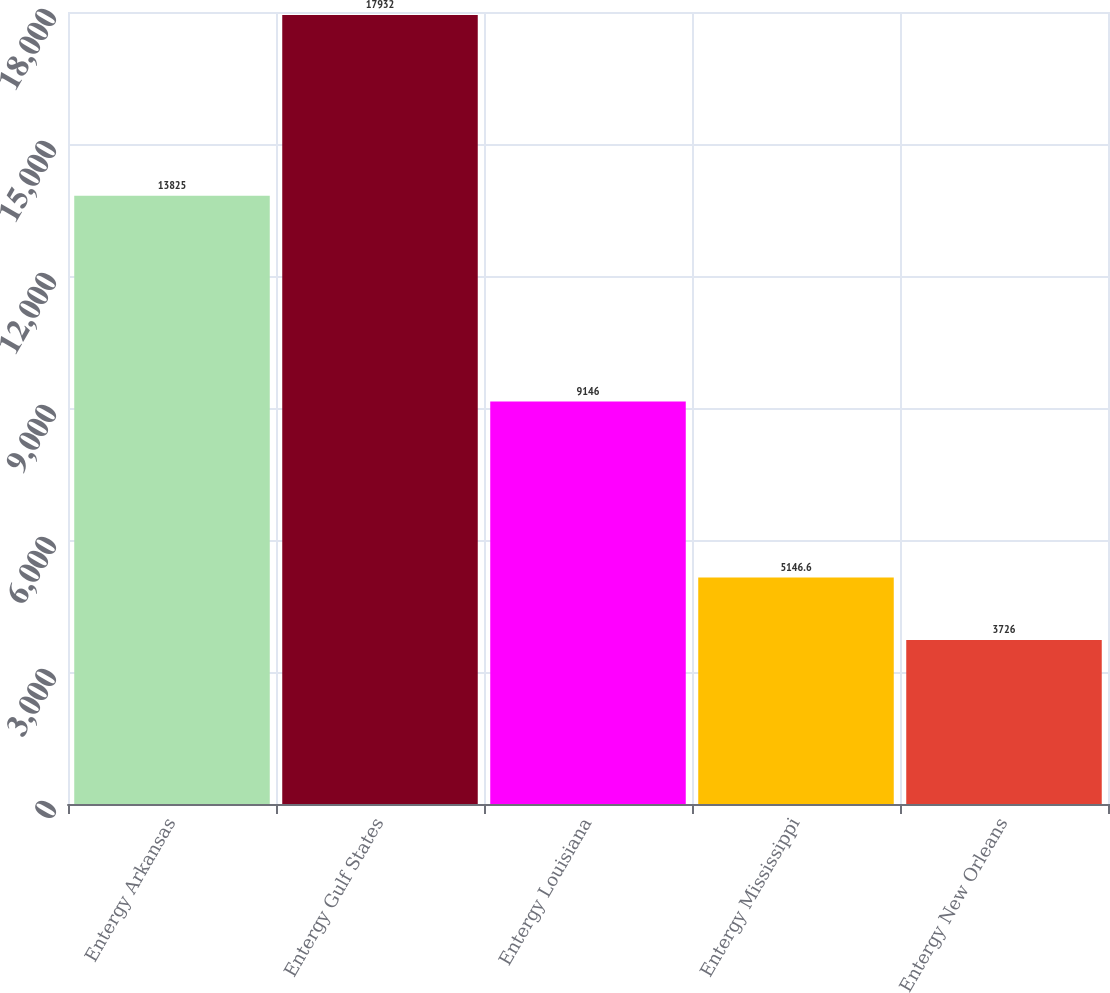Convert chart. <chart><loc_0><loc_0><loc_500><loc_500><bar_chart><fcel>Entergy Arkansas<fcel>Entergy Gulf States<fcel>Entergy Louisiana<fcel>Entergy Mississippi<fcel>Entergy New Orleans<nl><fcel>13825<fcel>17932<fcel>9146<fcel>5146.6<fcel>3726<nl></chart> 